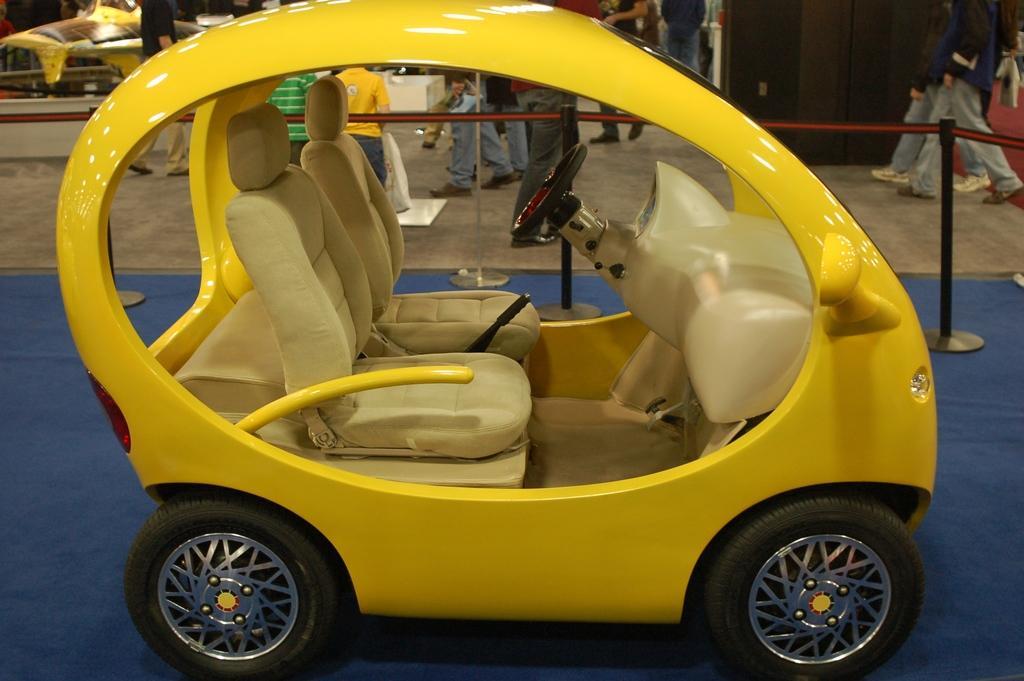Could you give a brief overview of what you see in this image? In this image we can see a motor vehicle on the carpet. In the background we can see poles, persons walking on the floor and cupboards. 